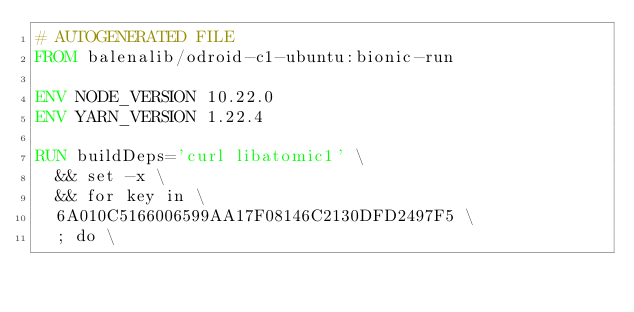<code> <loc_0><loc_0><loc_500><loc_500><_Dockerfile_># AUTOGENERATED FILE
FROM balenalib/odroid-c1-ubuntu:bionic-run

ENV NODE_VERSION 10.22.0
ENV YARN_VERSION 1.22.4

RUN buildDeps='curl libatomic1' \
	&& set -x \
	&& for key in \
	6A010C5166006599AA17F08146C2130DFD2497F5 \
	; do \</code> 